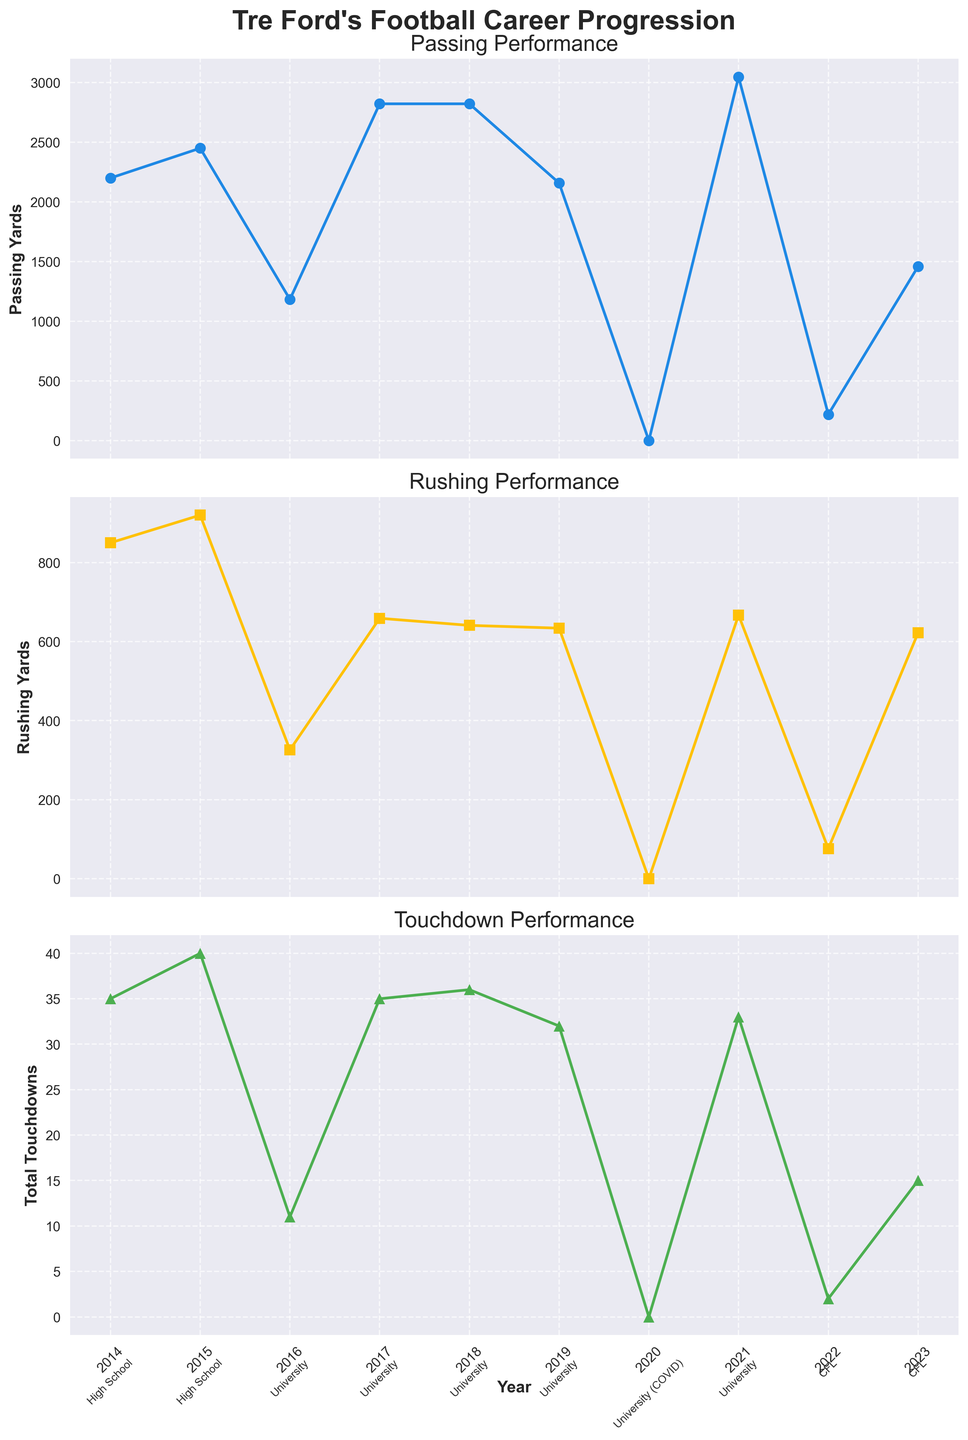What year did Tre Ford have the highest passing yards during his university career? In the subplot showing Passing Performance, look for the highest point during the university years, excluding the high school and CFL data points. In 2021, the plot shows the highest point in passing yards during his university career.
Answer: 2021 How did Tre Ford's rushing yards change from 2014 to 2015? Compare the height of the markers in the subplot for Rushing Performance for the years 2014 and 2015. In 2015, the rushing yards increase compared to 2014.
Answer: Increased What was the combined total touchdowns in 2017 and 2018? Sum up the total touchdowns for the years 2017 and 2018 as seen in the Total Touchdown Performance subplot. 2017 has 35 touchdowns, and 2018 has 36, so the combined total is 35 + 36.
Answer: 71 Which year shows the greatest difference between passing yards and rushing yards, and what is that difference? Calculate the absolute difference between passing yards and rushing yards for each year, and find the year with the highest difference. In 2017, the difference is \(2822 - 659 = 2163 \), which is the greatest.
Answer: 2017, 2163 In which year of his CFL career did Tre Ford achieve higher rushing yards, and by how much was it higher compared to the other year? Compare the rushing yards in 2022 and 2023 from the Rushing Performance subplot. In 2023, he had 622 rushing yards compared to 76 in 2022. The difference is \(622 - 76 \).
Answer: 2023, 546 How many passing yards did Tre Ford have cumulatively during his high school career? Sum up the passing yards for the years 2014 and 2015 from the Passing Performance subplot. He had \(2200 + 2450 \) passing yards in high school.
Answer: 4650 During which year did Tre Ford have zero performance statistics, and why? Look for the year where all subplot values are zero. In 2020, he had no statistics, and this corresponds to the COVID-19 pandemic according to the level annotation.
Answer: 2020, COVID-19 pandemic How does the number of total touchdowns in Tre Ford's rookie CFL season compare to his final university season? Compare the markers for Total Touchdowns in 2022 and 2021 in the Total Touchdown Performance subplot. He had 2 touchdowns in 2022 and 33 in 2021.
Answer: 2022 had 31 fewer Which performance category (passing, rushing, or touchdowns) shows the most significant drop from university to CFL in Tre Ford's data? Compare the overall trends and numerical drops from his last university season (2021) to his first CFL season (2022) in all three subplots. The Passing Performance subplot shows a drop from 3047 to 219 yards, which is the most significant.
Answer: Passing Performance In which university year did Tre Ford achieve the same passing yards, and what were they? Identify years in the Passing Performance subplot with identical markers. In 2017 and 2018, the passing yards both are 2822.
Answer: 2017 and 2018, 2822 